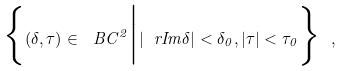Convert formula to latex. <formula><loc_0><loc_0><loc_500><loc_500>\Big \{ ( \delta , \tau ) \in \ B C ^ { 2 } \Big | | \ r I m \delta | < \delta _ { 0 } , | \tau | < \tau _ { 0 } \Big \} \ ,</formula> 